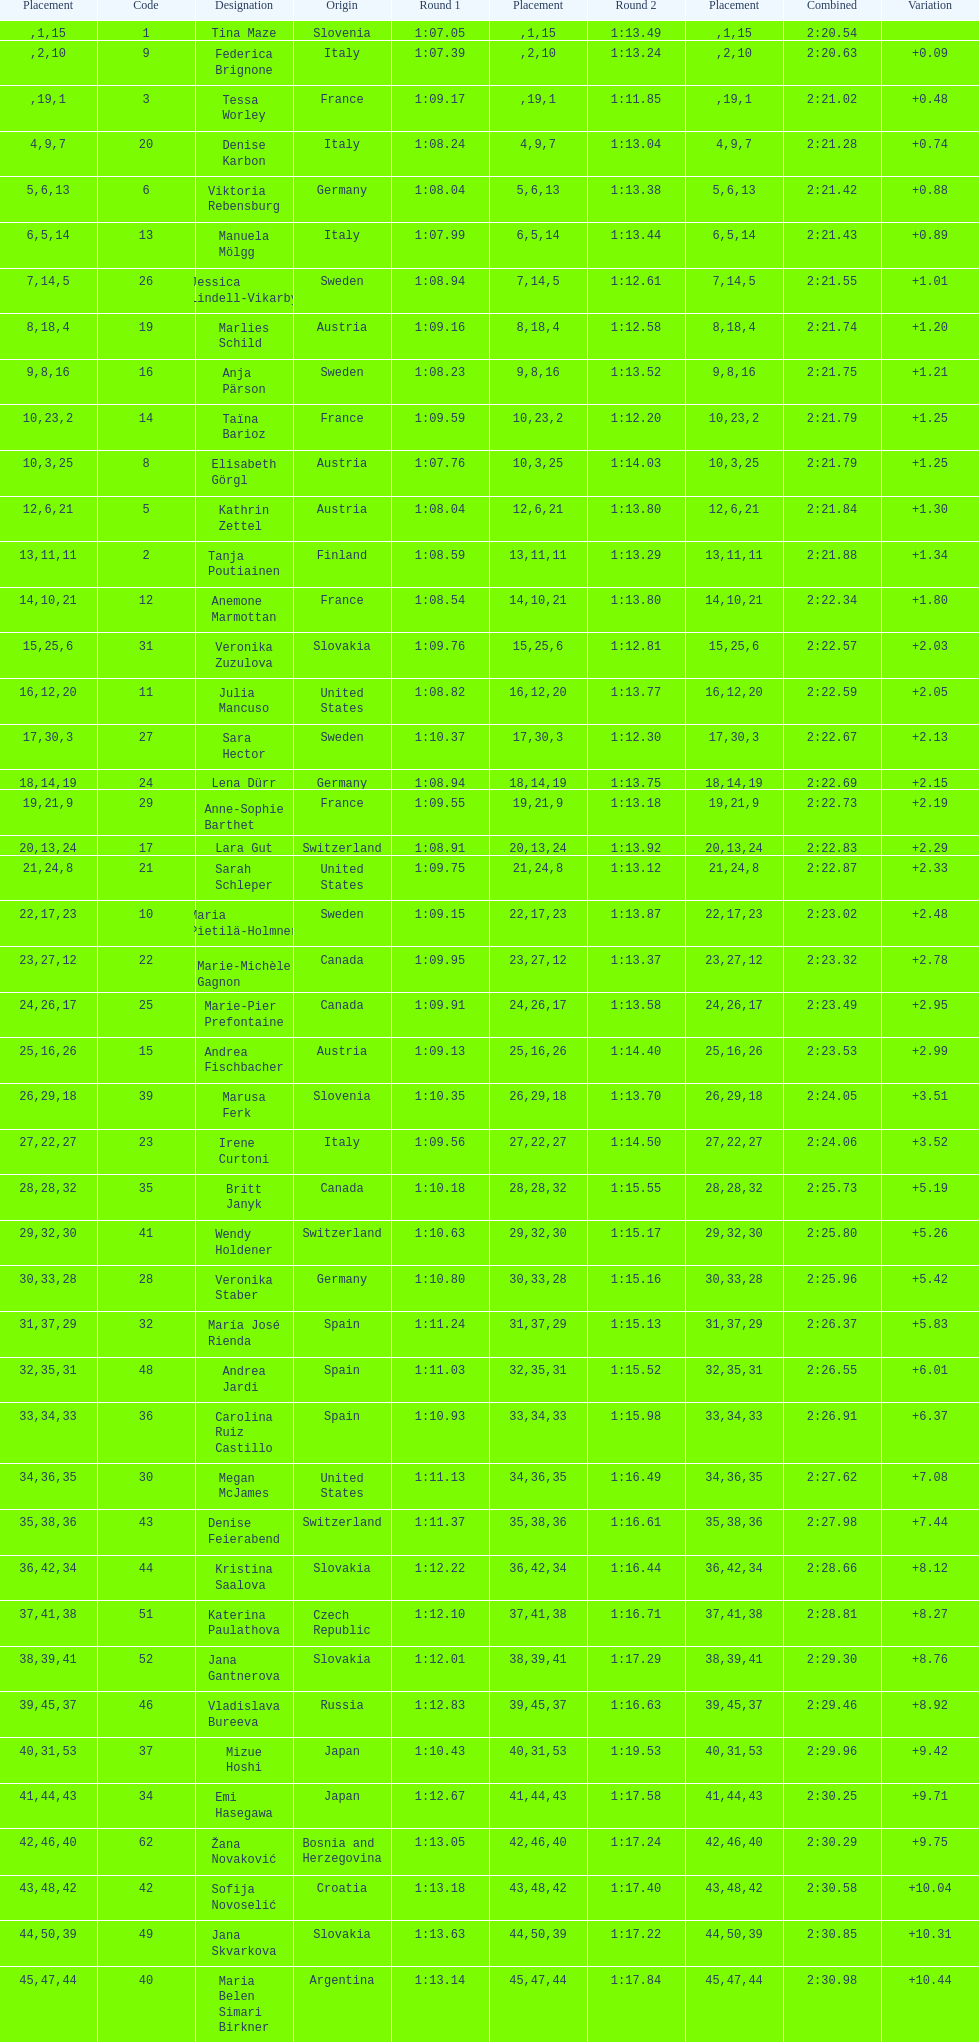Who ranked next after federica brignone? Tessa Worley. 